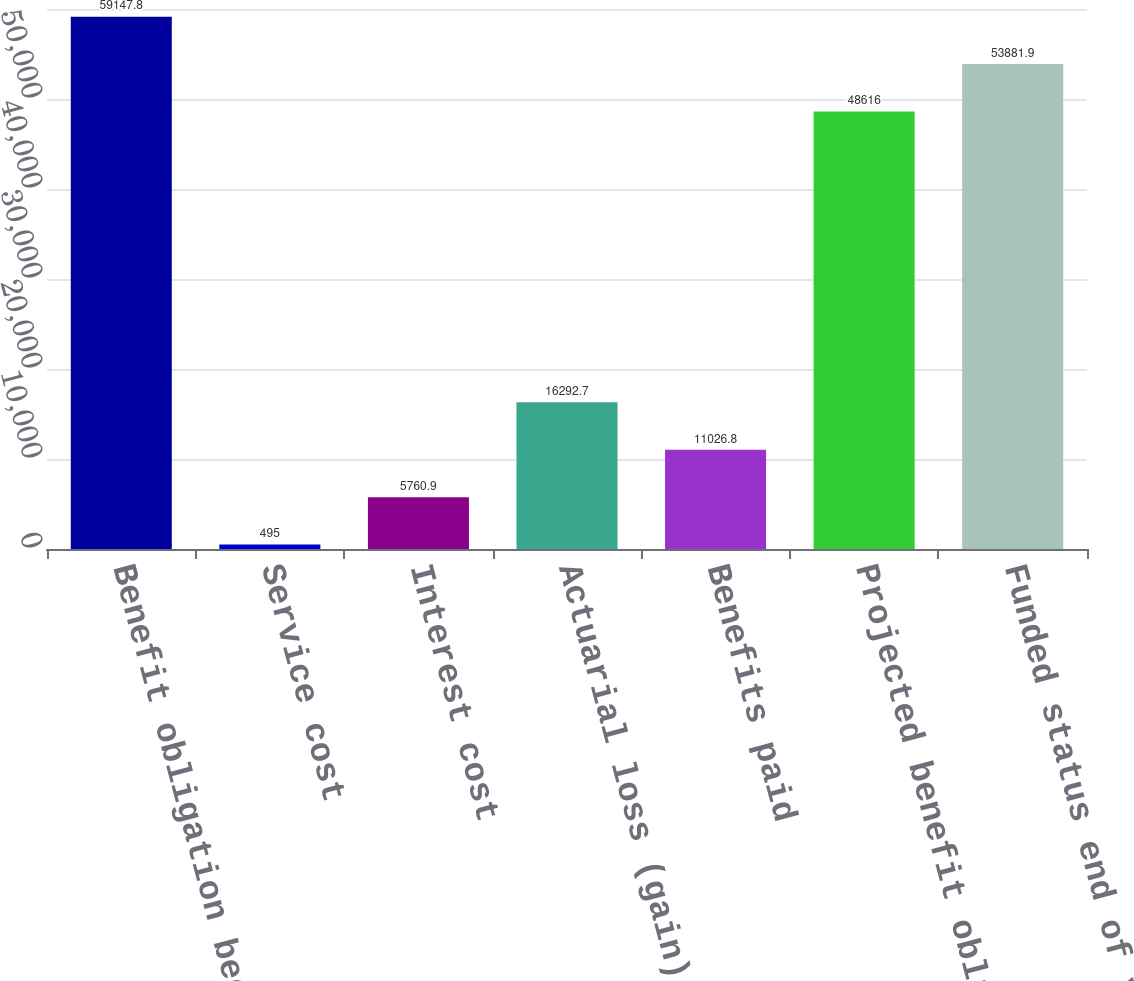<chart> <loc_0><loc_0><loc_500><loc_500><bar_chart><fcel>Benefit obligation beginning<fcel>Service cost<fcel>Interest cost<fcel>Actuarial loss (gain)<fcel>Benefits paid<fcel>Projected benefit obligation<fcel>Funded status end of year<nl><fcel>59147.8<fcel>495<fcel>5760.9<fcel>16292.7<fcel>11026.8<fcel>48616<fcel>53881.9<nl></chart> 